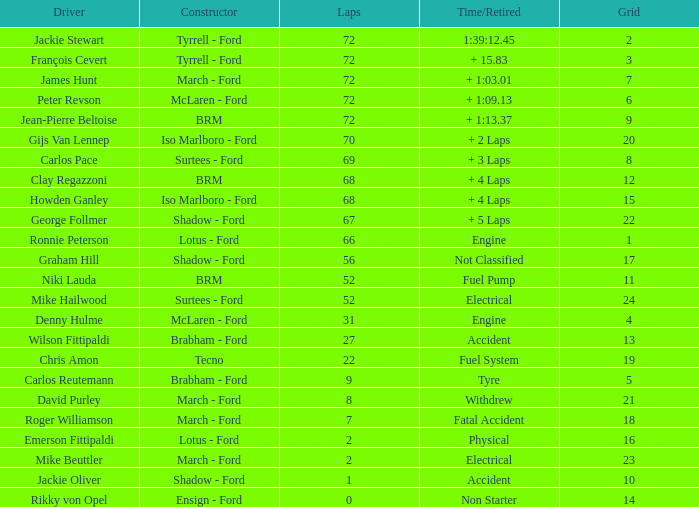What is the top lap that had a tyre time? 9.0. 